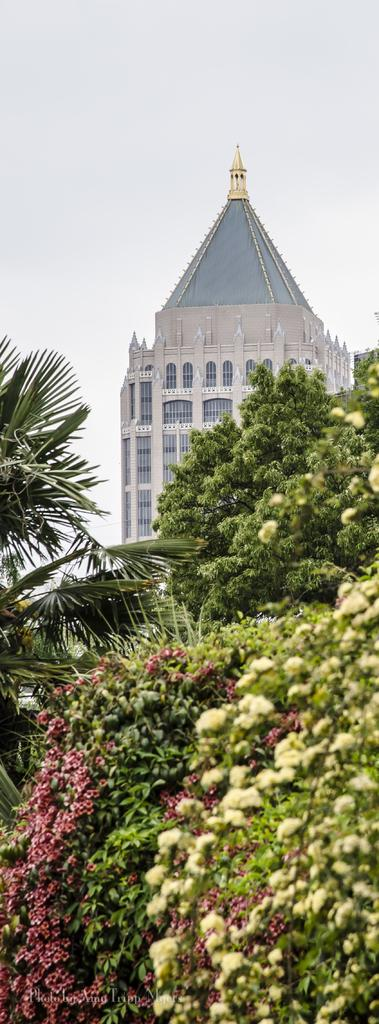What type of vegetation is present in the image? There are flower plants and trees in the image. What type of structure can be seen in the image? There is a building in the image. What can be seen in the background of the image? The sky is visible in the background of the image. What type of reaction does the suit have to the flower plants in the image? There is no suit present in the image, so it is not possible to determine any reaction. 